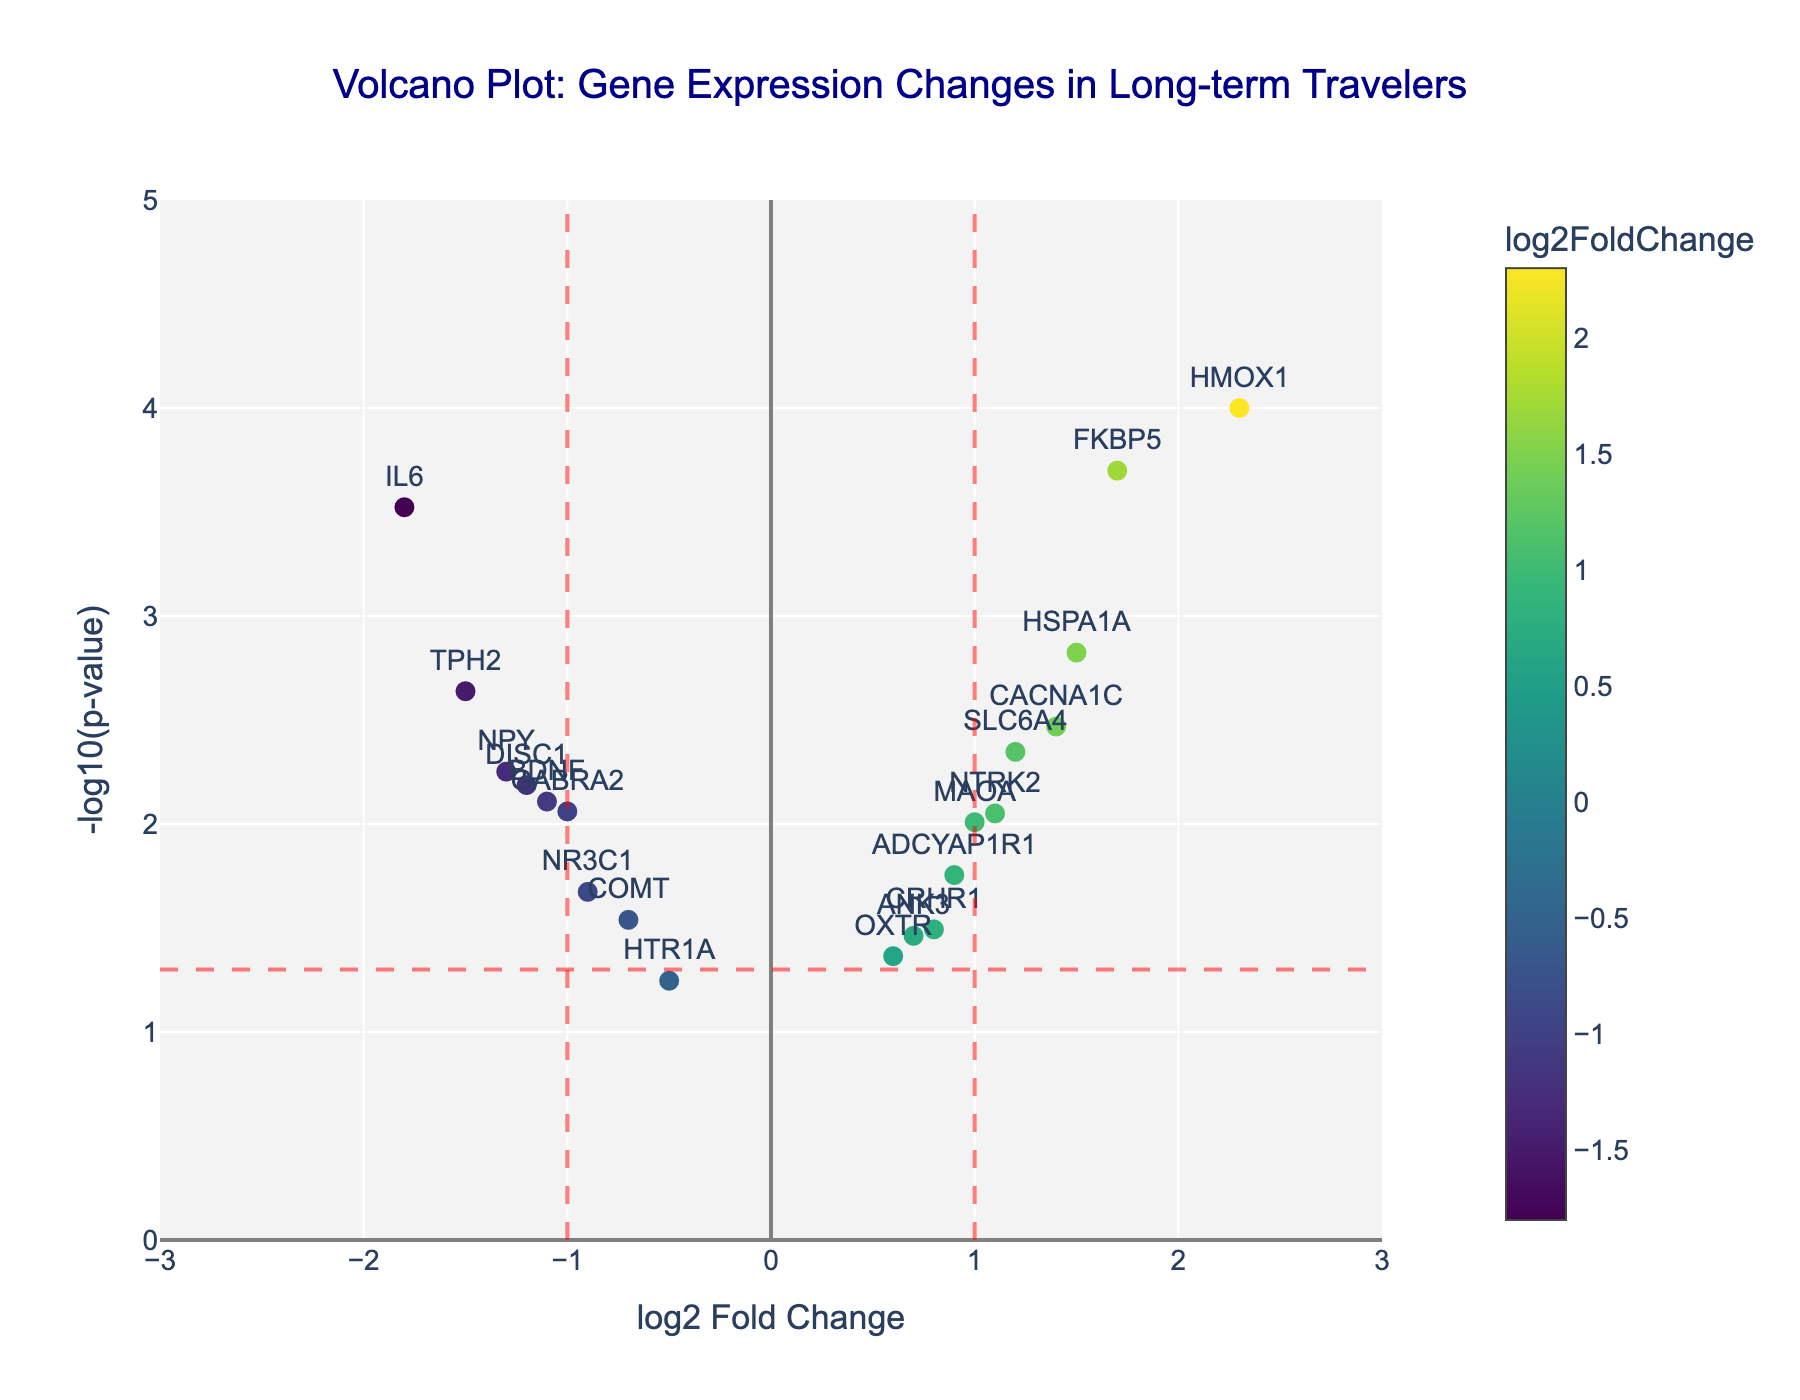What is the title of the plot? The title is generally located at the top of the plot and is written in a larger font size to easily convey the main topic of the plot.
Answer: Volcano Plot: Gene Expression Changes in Long-term Travelers What does the x-axis represent? The x-axis label can be found directly below the x-axis and typically describes what the values in the horizontal direction represent.
Answer: log2 Fold Change What does the y-axis represent? The y-axis label can be found directly next to the y-axis and typically describes what the values in the vertical direction represent.
Answer: -log10(p-value) Which gene has the highest log2 fold change? To find the gene with the highest log2 fold change, look for the data point farthest to the right on the x-axis.
Answer: HMOX1 Which gene has the most significant p-value? The most significant p-value corresponds to the highest -log10(p-value), so look for the data point highest on the y-axis.
Answer: HMOX1 Identify a gene with a negative log2 fold change but a significant p-value (less than 0.05). Look for data points positioned to the left of the zero on the x-axis (indicating negative log2 fold change) and above the horizontal red dashed line (indicating significant p-value).
Answer: IL6 How many genes are downregulated (negative log2 fold change) and have a significant p-value (less than 0.05)? Count the number of data points to the left of zero on the x-axis and above the horizontal red dashed line. There are four such genes: IL6, BDNF, TPH2, and DISC1.
Answer: 4 What is the log2 fold change of gene NPY? Locate the annotation for NPY in the plot and read its corresponding x-axis value, which represents the log2 fold change.
Answer: -1.3 Compare the expression changes of HMOX1 and IL6. Which one is upregulated and by how much? HMOX1 has a log2 fold change to the right of zero (positive) and IL6 to the left of zero (negative). HMOX1 is upregulated by 2.3, while IL6 is downregulated by -1.8. HMOX1 is upregulated by 2.3 - (-1.8) = 4.1 more than IL6.
Answer: HMOX1 is upregulated by 4.1 What color scale is used in the plot and what does it represent? The color scale is visible as a vertical bar in the plot legend and ranges from lighter to darker shades. It represents the log2 fold change, with colors differentiating the intensity of upregulation or downregulation.
Answer: Viridis scale representing log2 Fold Change 